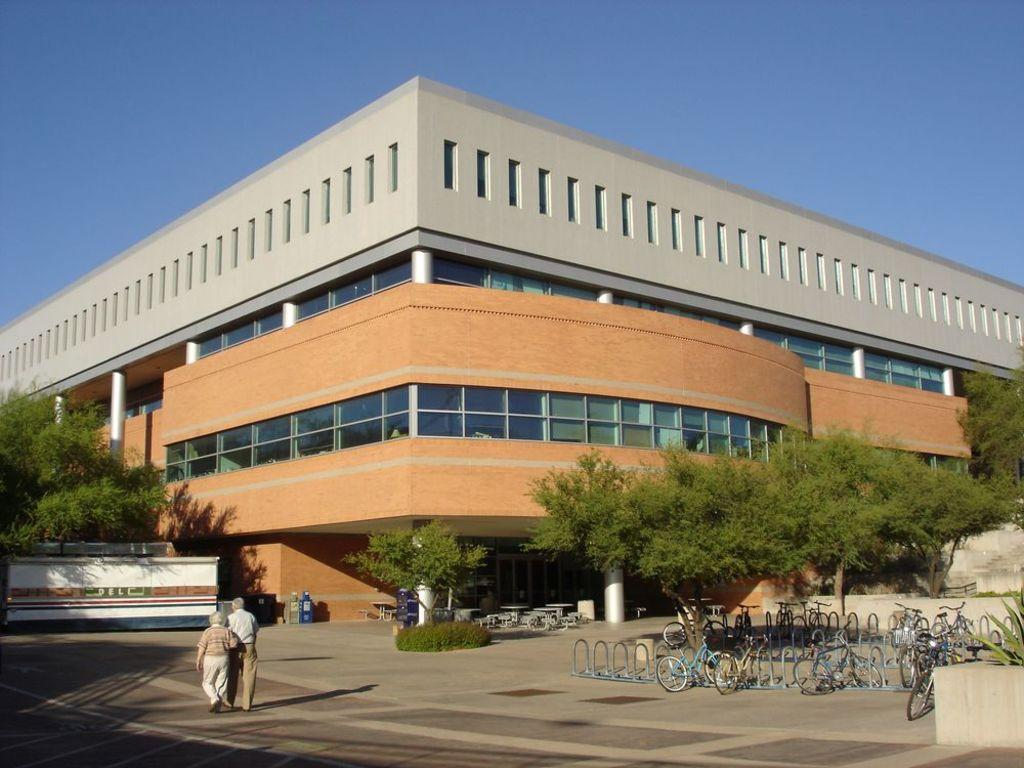What type of vegetation can be seen in the image? There are trees in the image. What mode of transportation is visible in the image? There are bicycles in the image. What are the two persons in the image doing? They are walking on the road in the bottom left of the image. What is visible at the top of the image? The sky is visible at the top of the image. How many fingers can be seen on the table in the image? There is no table or fingers present in the image. What type of ear is visible on the person walking in the image? There is no ear visible on the person walking in the image; only their legs and feet can be seen. 